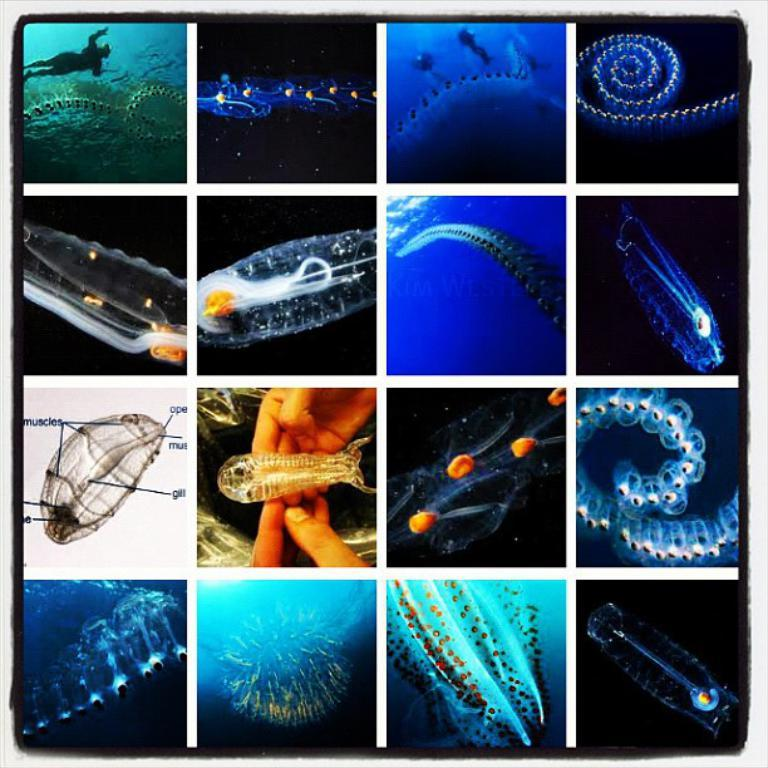What type of artwork is the image? The image is a collage. How many images are included in the collage? There are sixteen images in the collage. What is the subject matter of each image in the collage? Each image contains a different type of jellyfish. How many eggs are used to make the whip in the image? There are no eggs or whips present in the image; it is a collage of jellyfish images. 